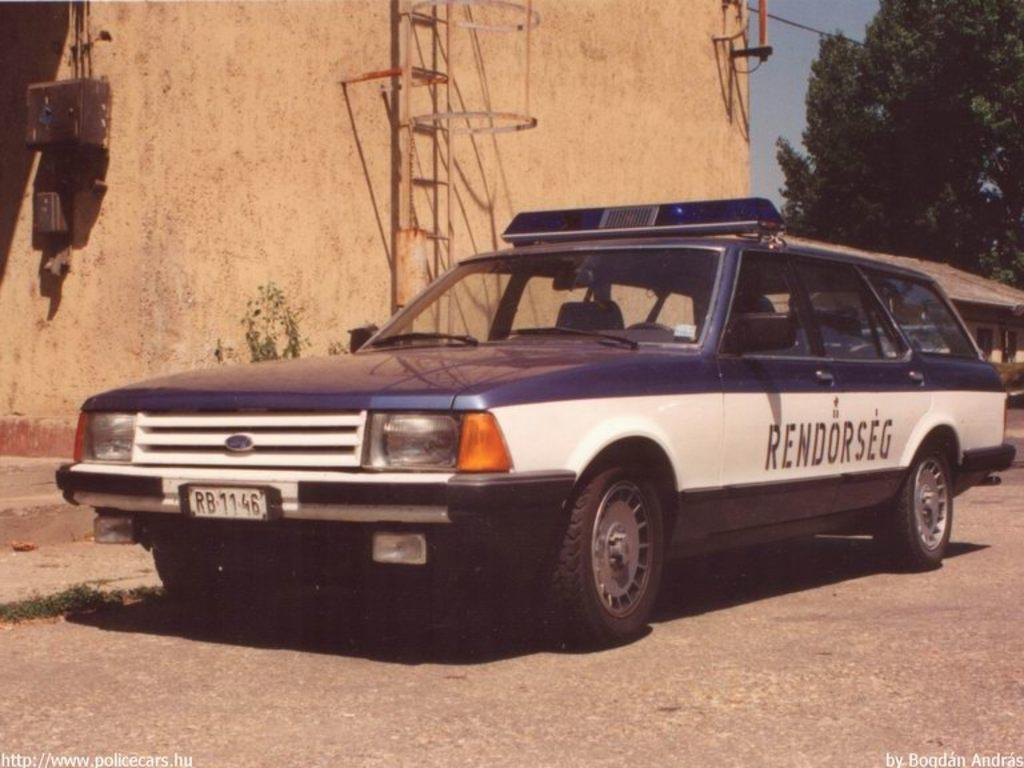What is the main subject of the image? The main subject of the image is a car on the road. What can be seen on the left side of the image? There is a building on the left side of the image. What is present on the right side of the image? There is a tree on the right side of the image. How many legs can be seen on the car in the image? Cars do not have legs, so there are no legs visible in the image. 